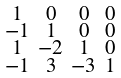<formula> <loc_0><loc_0><loc_500><loc_500>\begin{smallmatrix} 1 & 0 & 0 & 0 \\ - 1 & 1 & 0 & 0 \\ 1 & - 2 & 1 & 0 \\ - 1 & 3 & - 3 & 1 \end{smallmatrix}</formula> 